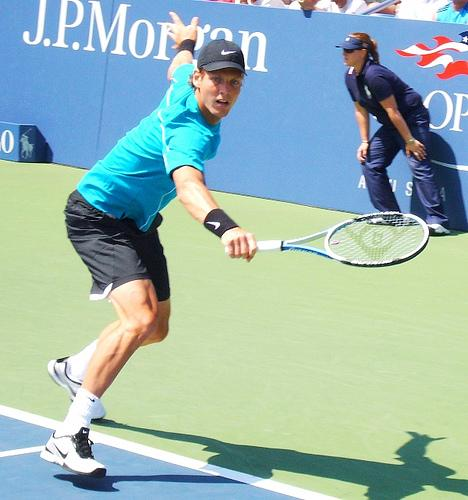What type of stroke is being used?

Choices:
A) breast
B) side
C) backhand
D) forehand forehand 